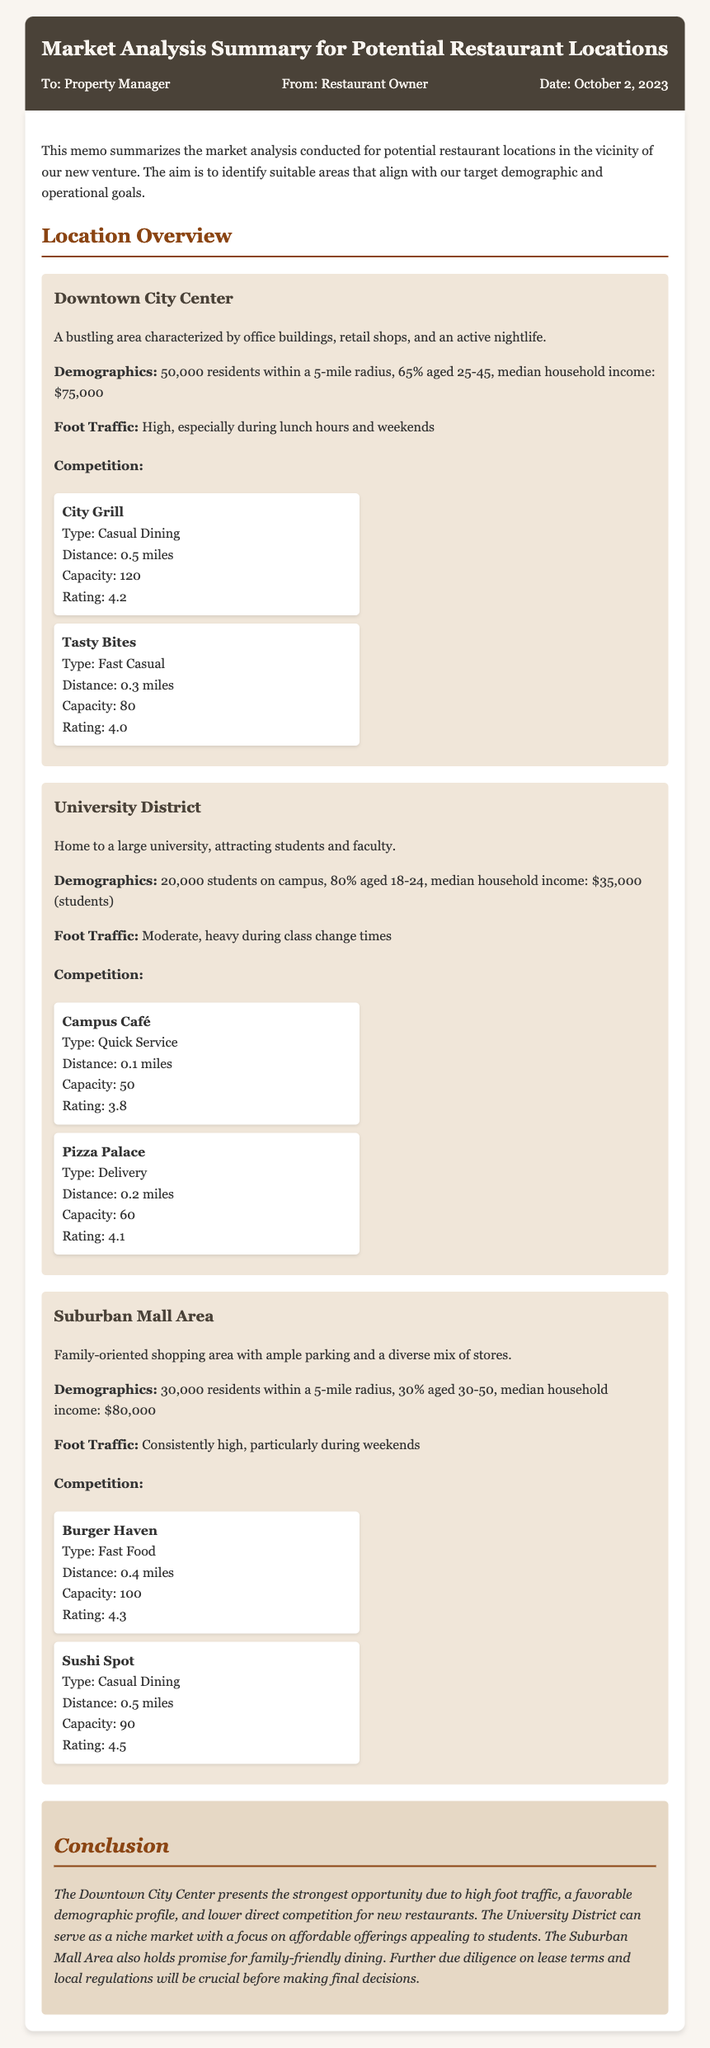What is the date of the memo? The date of the memo is mentioned in the details at the top of the document, which is October 2, 2023.
Answer: October 2, 2023 What is the median household income in the Downtown City Center? The median household income for the Downtown City Center is specified in the demographics section as $75,000.
Answer: $75,000 How many competitors are listed for the University District? The competitors for the University District are detailed, with two mentioned in the competition section.
Answer: 2 Which location has the highest average rating of the competitors? By evaluating each competitor's rating in all locations, Sushi Spot with a rating of 4.5 is identified as the highest.
Answer: 4.5 What is the target demographic age range for the Downtown City Center? The demographics indicate that 65% of residents in the Downtown City Center fall within the age range of 25-45 years.
Answer: 25-45 Which area has the highest foot traffic? The foot traffic for the Downtown City Center is characterized as high, especially during lunch hours and weekends, making it the highest.
Answer: Downtown City Center What type of dining establishments are mentioned for the Suburban Mall Area? The competitors in the Suburban Mall Area are identified as Fast Food and Casual Dining types.
Answer: Fast Food and Casual Dining What conclusion is drawn about the University District? The memo points out that the University District can serve as a niche market focusing on affordable offerings appealing to students.
Answer: Niche market with affordable offerings 